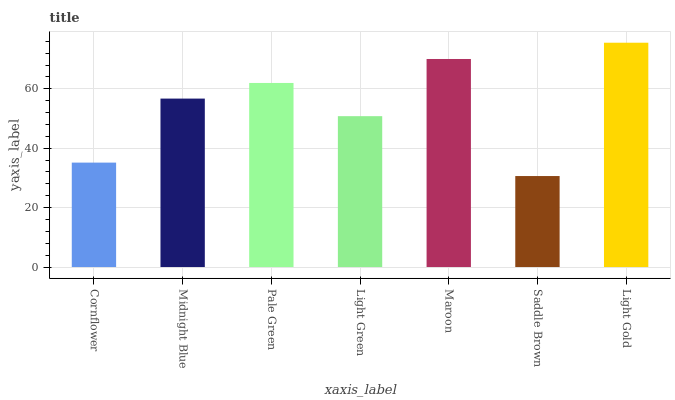Is Midnight Blue the minimum?
Answer yes or no. No. Is Midnight Blue the maximum?
Answer yes or no. No. Is Midnight Blue greater than Cornflower?
Answer yes or no. Yes. Is Cornflower less than Midnight Blue?
Answer yes or no. Yes. Is Cornflower greater than Midnight Blue?
Answer yes or no. No. Is Midnight Blue less than Cornflower?
Answer yes or no. No. Is Midnight Blue the high median?
Answer yes or no. Yes. Is Midnight Blue the low median?
Answer yes or no. Yes. Is Pale Green the high median?
Answer yes or no. No. Is Pale Green the low median?
Answer yes or no. No. 